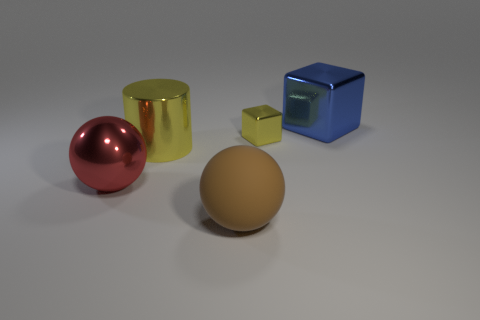There is a small thing that is the same color as the large cylinder; what material is it?
Offer a very short reply. Metal. How many purple objects are either tiny matte balls or large rubber spheres?
Give a very brief answer. 0. What number of other objects are the same size as the blue metal object?
Provide a short and direct response. 3. Are the big thing right of the big brown thing and the brown ball made of the same material?
Keep it short and to the point. No. There is a shiny cube that is on the left side of the large blue thing; are there any small objects behind it?
Give a very brief answer. No. What material is the big brown object that is the same shape as the red object?
Give a very brief answer. Rubber. Are there more blue things in front of the matte object than tiny yellow blocks behind the tiny metallic block?
Provide a short and direct response. No. What shape is the tiny thing that is the same material as the yellow cylinder?
Provide a short and direct response. Cube. Are there more large metal things that are right of the big matte ball than purple metallic blocks?
Make the answer very short. Yes. What number of large shiny balls are the same color as the big shiny cylinder?
Ensure brevity in your answer.  0. 